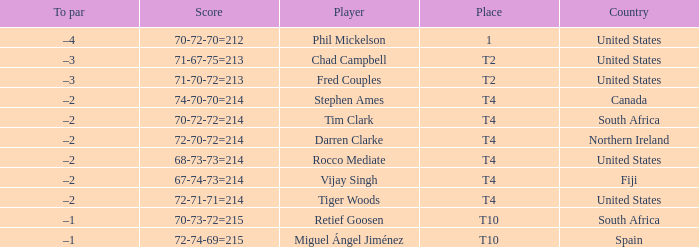What was the score for Spain? 72-74-69=215. 